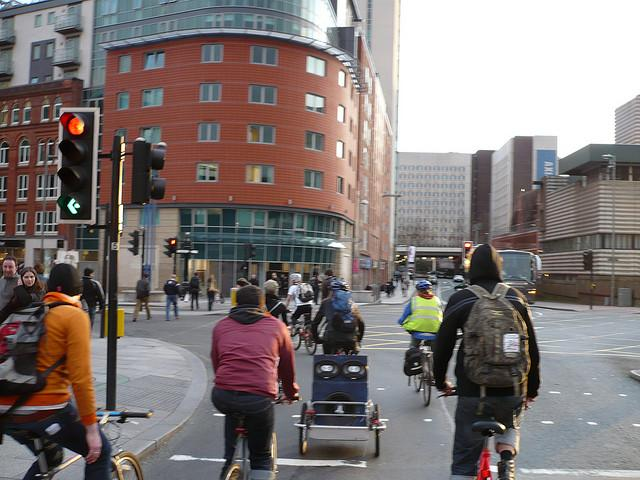What type of action is allowed by the traffic light? left turn 